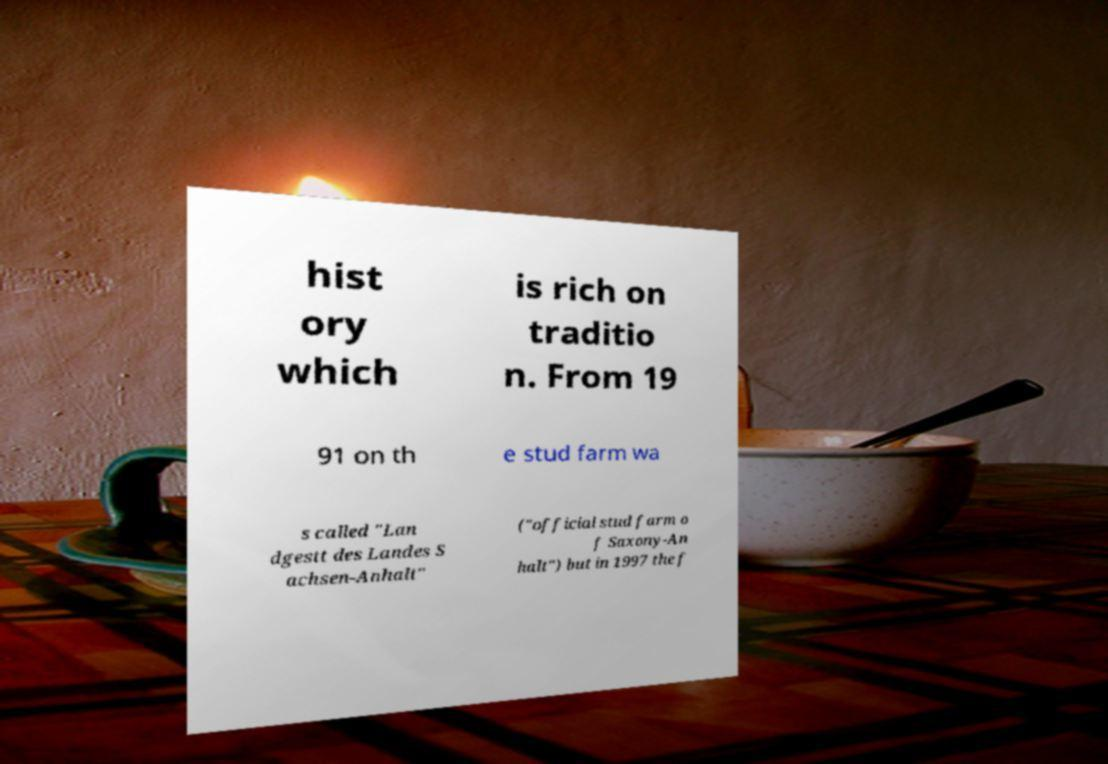For documentation purposes, I need the text within this image transcribed. Could you provide that? hist ory which is rich on traditio n. From 19 91 on th e stud farm wa s called "Lan dgestt des Landes S achsen-Anhalt" ("official stud farm o f Saxony-An halt") but in 1997 the f 